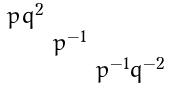Convert formula to latex. <formula><loc_0><loc_0><loc_500><loc_500>\begin{smallmatrix} p q ^ { 2 } & & \\ & p ^ { - 1 } & \\ & & p ^ { - 1 } q ^ { - 2 } \end{smallmatrix}</formula> 